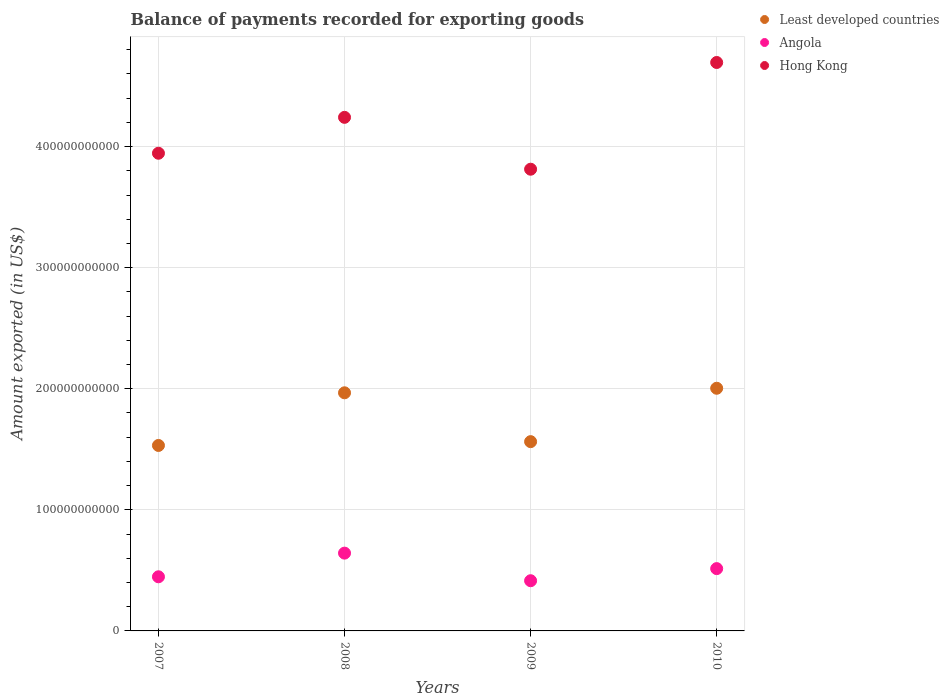How many different coloured dotlines are there?
Your response must be concise. 3. What is the amount exported in Least developed countries in 2009?
Offer a terse response. 1.56e+11. Across all years, what is the maximum amount exported in Angola?
Offer a terse response. 6.42e+1. Across all years, what is the minimum amount exported in Hong Kong?
Give a very brief answer. 3.81e+11. What is the total amount exported in Hong Kong in the graph?
Provide a short and direct response. 1.67e+12. What is the difference between the amount exported in Hong Kong in 2007 and that in 2010?
Your response must be concise. -7.50e+1. What is the difference between the amount exported in Least developed countries in 2009 and the amount exported in Hong Kong in 2007?
Your response must be concise. -2.38e+11. What is the average amount exported in Hong Kong per year?
Provide a succinct answer. 4.17e+11. In the year 2007, what is the difference between the amount exported in Angola and amount exported in Least developed countries?
Ensure brevity in your answer.  -1.08e+11. What is the ratio of the amount exported in Angola in 2007 to that in 2009?
Provide a succinct answer. 1.08. Is the amount exported in Least developed countries in 2008 less than that in 2009?
Provide a succinct answer. No. Is the difference between the amount exported in Angola in 2008 and 2010 greater than the difference between the amount exported in Least developed countries in 2008 and 2010?
Ensure brevity in your answer.  Yes. What is the difference between the highest and the second highest amount exported in Hong Kong?
Your response must be concise. 4.53e+1. What is the difference between the highest and the lowest amount exported in Angola?
Your answer should be very brief. 2.28e+1. In how many years, is the amount exported in Angola greater than the average amount exported in Angola taken over all years?
Provide a succinct answer. 2. Is the sum of the amount exported in Least developed countries in 2009 and 2010 greater than the maximum amount exported in Hong Kong across all years?
Keep it short and to the point. No. Does the amount exported in Angola monotonically increase over the years?
Your answer should be very brief. No. How many dotlines are there?
Provide a succinct answer. 3. What is the difference between two consecutive major ticks on the Y-axis?
Provide a succinct answer. 1.00e+11. Does the graph contain any zero values?
Keep it short and to the point. No. What is the title of the graph?
Your answer should be compact. Balance of payments recorded for exporting goods. What is the label or title of the Y-axis?
Your response must be concise. Amount exported (in US$). What is the Amount exported (in US$) of Least developed countries in 2007?
Offer a very short reply. 1.53e+11. What is the Amount exported (in US$) of Angola in 2007?
Ensure brevity in your answer.  4.47e+1. What is the Amount exported (in US$) of Hong Kong in 2007?
Offer a very short reply. 3.94e+11. What is the Amount exported (in US$) of Least developed countries in 2008?
Keep it short and to the point. 1.97e+11. What is the Amount exported (in US$) of Angola in 2008?
Keep it short and to the point. 6.42e+1. What is the Amount exported (in US$) in Hong Kong in 2008?
Make the answer very short. 4.24e+11. What is the Amount exported (in US$) in Least developed countries in 2009?
Make the answer very short. 1.56e+11. What is the Amount exported (in US$) in Angola in 2009?
Provide a short and direct response. 4.15e+1. What is the Amount exported (in US$) in Hong Kong in 2009?
Provide a short and direct response. 3.81e+11. What is the Amount exported (in US$) of Least developed countries in 2010?
Make the answer very short. 2.00e+11. What is the Amount exported (in US$) in Angola in 2010?
Ensure brevity in your answer.  5.15e+1. What is the Amount exported (in US$) in Hong Kong in 2010?
Your response must be concise. 4.69e+11. Across all years, what is the maximum Amount exported (in US$) of Least developed countries?
Keep it short and to the point. 2.00e+11. Across all years, what is the maximum Amount exported (in US$) of Angola?
Make the answer very short. 6.42e+1. Across all years, what is the maximum Amount exported (in US$) of Hong Kong?
Provide a short and direct response. 4.69e+11. Across all years, what is the minimum Amount exported (in US$) of Least developed countries?
Ensure brevity in your answer.  1.53e+11. Across all years, what is the minimum Amount exported (in US$) of Angola?
Ensure brevity in your answer.  4.15e+1. Across all years, what is the minimum Amount exported (in US$) of Hong Kong?
Provide a succinct answer. 3.81e+11. What is the total Amount exported (in US$) of Least developed countries in the graph?
Your response must be concise. 7.07e+11. What is the total Amount exported (in US$) of Angola in the graph?
Give a very brief answer. 2.02e+11. What is the total Amount exported (in US$) in Hong Kong in the graph?
Make the answer very short. 1.67e+12. What is the difference between the Amount exported (in US$) in Least developed countries in 2007 and that in 2008?
Provide a succinct answer. -4.35e+1. What is the difference between the Amount exported (in US$) in Angola in 2007 and that in 2008?
Make the answer very short. -1.95e+1. What is the difference between the Amount exported (in US$) in Hong Kong in 2007 and that in 2008?
Your response must be concise. -2.96e+1. What is the difference between the Amount exported (in US$) of Least developed countries in 2007 and that in 2009?
Keep it short and to the point. -3.15e+09. What is the difference between the Amount exported (in US$) in Angola in 2007 and that in 2009?
Provide a succinct answer. 3.26e+09. What is the difference between the Amount exported (in US$) of Hong Kong in 2007 and that in 2009?
Give a very brief answer. 1.32e+1. What is the difference between the Amount exported (in US$) of Least developed countries in 2007 and that in 2010?
Your answer should be compact. -4.72e+1. What is the difference between the Amount exported (in US$) of Angola in 2007 and that in 2010?
Offer a terse response. -6.74e+09. What is the difference between the Amount exported (in US$) of Hong Kong in 2007 and that in 2010?
Your answer should be compact. -7.50e+1. What is the difference between the Amount exported (in US$) of Least developed countries in 2008 and that in 2009?
Your response must be concise. 4.03e+1. What is the difference between the Amount exported (in US$) of Angola in 2008 and that in 2009?
Your answer should be very brief. 2.28e+1. What is the difference between the Amount exported (in US$) in Hong Kong in 2008 and that in 2009?
Ensure brevity in your answer.  4.28e+1. What is the difference between the Amount exported (in US$) in Least developed countries in 2008 and that in 2010?
Offer a very short reply. -3.75e+09. What is the difference between the Amount exported (in US$) in Angola in 2008 and that in 2010?
Your answer should be very brief. 1.28e+1. What is the difference between the Amount exported (in US$) of Hong Kong in 2008 and that in 2010?
Offer a terse response. -4.53e+1. What is the difference between the Amount exported (in US$) in Least developed countries in 2009 and that in 2010?
Offer a terse response. -4.41e+1. What is the difference between the Amount exported (in US$) of Angola in 2009 and that in 2010?
Keep it short and to the point. -1.00e+1. What is the difference between the Amount exported (in US$) of Hong Kong in 2009 and that in 2010?
Your response must be concise. -8.81e+1. What is the difference between the Amount exported (in US$) of Least developed countries in 2007 and the Amount exported (in US$) of Angola in 2008?
Make the answer very short. 8.89e+1. What is the difference between the Amount exported (in US$) of Least developed countries in 2007 and the Amount exported (in US$) of Hong Kong in 2008?
Your response must be concise. -2.71e+11. What is the difference between the Amount exported (in US$) in Angola in 2007 and the Amount exported (in US$) in Hong Kong in 2008?
Make the answer very short. -3.79e+11. What is the difference between the Amount exported (in US$) of Least developed countries in 2007 and the Amount exported (in US$) of Angola in 2009?
Provide a short and direct response. 1.12e+11. What is the difference between the Amount exported (in US$) in Least developed countries in 2007 and the Amount exported (in US$) in Hong Kong in 2009?
Keep it short and to the point. -2.28e+11. What is the difference between the Amount exported (in US$) of Angola in 2007 and the Amount exported (in US$) of Hong Kong in 2009?
Keep it short and to the point. -3.37e+11. What is the difference between the Amount exported (in US$) in Least developed countries in 2007 and the Amount exported (in US$) in Angola in 2010?
Offer a very short reply. 1.02e+11. What is the difference between the Amount exported (in US$) in Least developed countries in 2007 and the Amount exported (in US$) in Hong Kong in 2010?
Offer a very short reply. -3.16e+11. What is the difference between the Amount exported (in US$) of Angola in 2007 and the Amount exported (in US$) of Hong Kong in 2010?
Keep it short and to the point. -4.25e+11. What is the difference between the Amount exported (in US$) of Least developed countries in 2008 and the Amount exported (in US$) of Angola in 2009?
Offer a very short reply. 1.55e+11. What is the difference between the Amount exported (in US$) of Least developed countries in 2008 and the Amount exported (in US$) of Hong Kong in 2009?
Give a very brief answer. -1.85e+11. What is the difference between the Amount exported (in US$) of Angola in 2008 and the Amount exported (in US$) of Hong Kong in 2009?
Ensure brevity in your answer.  -3.17e+11. What is the difference between the Amount exported (in US$) of Least developed countries in 2008 and the Amount exported (in US$) of Angola in 2010?
Your response must be concise. 1.45e+11. What is the difference between the Amount exported (in US$) in Least developed countries in 2008 and the Amount exported (in US$) in Hong Kong in 2010?
Your answer should be compact. -2.73e+11. What is the difference between the Amount exported (in US$) of Angola in 2008 and the Amount exported (in US$) of Hong Kong in 2010?
Provide a short and direct response. -4.05e+11. What is the difference between the Amount exported (in US$) of Least developed countries in 2009 and the Amount exported (in US$) of Angola in 2010?
Provide a succinct answer. 1.05e+11. What is the difference between the Amount exported (in US$) in Least developed countries in 2009 and the Amount exported (in US$) in Hong Kong in 2010?
Provide a short and direct response. -3.13e+11. What is the difference between the Amount exported (in US$) of Angola in 2009 and the Amount exported (in US$) of Hong Kong in 2010?
Your answer should be compact. -4.28e+11. What is the average Amount exported (in US$) in Least developed countries per year?
Your answer should be compact. 1.77e+11. What is the average Amount exported (in US$) of Angola per year?
Provide a short and direct response. 5.05e+1. What is the average Amount exported (in US$) of Hong Kong per year?
Offer a very short reply. 4.17e+11. In the year 2007, what is the difference between the Amount exported (in US$) of Least developed countries and Amount exported (in US$) of Angola?
Your answer should be compact. 1.08e+11. In the year 2007, what is the difference between the Amount exported (in US$) in Least developed countries and Amount exported (in US$) in Hong Kong?
Your answer should be very brief. -2.41e+11. In the year 2007, what is the difference between the Amount exported (in US$) in Angola and Amount exported (in US$) in Hong Kong?
Your answer should be compact. -3.50e+11. In the year 2008, what is the difference between the Amount exported (in US$) of Least developed countries and Amount exported (in US$) of Angola?
Your answer should be compact. 1.32e+11. In the year 2008, what is the difference between the Amount exported (in US$) in Least developed countries and Amount exported (in US$) in Hong Kong?
Your answer should be very brief. -2.27e+11. In the year 2008, what is the difference between the Amount exported (in US$) of Angola and Amount exported (in US$) of Hong Kong?
Offer a terse response. -3.60e+11. In the year 2009, what is the difference between the Amount exported (in US$) of Least developed countries and Amount exported (in US$) of Angola?
Keep it short and to the point. 1.15e+11. In the year 2009, what is the difference between the Amount exported (in US$) in Least developed countries and Amount exported (in US$) in Hong Kong?
Provide a short and direct response. -2.25e+11. In the year 2009, what is the difference between the Amount exported (in US$) of Angola and Amount exported (in US$) of Hong Kong?
Your answer should be compact. -3.40e+11. In the year 2010, what is the difference between the Amount exported (in US$) in Least developed countries and Amount exported (in US$) in Angola?
Ensure brevity in your answer.  1.49e+11. In the year 2010, what is the difference between the Amount exported (in US$) of Least developed countries and Amount exported (in US$) of Hong Kong?
Give a very brief answer. -2.69e+11. In the year 2010, what is the difference between the Amount exported (in US$) of Angola and Amount exported (in US$) of Hong Kong?
Give a very brief answer. -4.18e+11. What is the ratio of the Amount exported (in US$) in Least developed countries in 2007 to that in 2008?
Keep it short and to the point. 0.78. What is the ratio of the Amount exported (in US$) of Angola in 2007 to that in 2008?
Your answer should be very brief. 0.7. What is the ratio of the Amount exported (in US$) in Hong Kong in 2007 to that in 2008?
Give a very brief answer. 0.93. What is the ratio of the Amount exported (in US$) of Least developed countries in 2007 to that in 2009?
Your response must be concise. 0.98. What is the ratio of the Amount exported (in US$) of Angola in 2007 to that in 2009?
Ensure brevity in your answer.  1.08. What is the ratio of the Amount exported (in US$) in Hong Kong in 2007 to that in 2009?
Make the answer very short. 1.03. What is the ratio of the Amount exported (in US$) of Least developed countries in 2007 to that in 2010?
Your response must be concise. 0.76. What is the ratio of the Amount exported (in US$) in Angola in 2007 to that in 2010?
Your answer should be compact. 0.87. What is the ratio of the Amount exported (in US$) of Hong Kong in 2007 to that in 2010?
Your answer should be compact. 0.84. What is the ratio of the Amount exported (in US$) of Least developed countries in 2008 to that in 2009?
Offer a very short reply. 1.26. What is the ratio of the Amount exported (in US$) in Angola in 2008 to that in 2009?
Your response must be concise. 1.55. What is the ratio of the Amount exported (in US$) of Hong Kong in 2008 to that in 2009?
Keep it short and to the point. 1.11. What is the ratio of the Amount exported (in US$) of Least developed countries in 2008 to that in 2010?
Ensure brevity in your answer.  0.98. What is the ratio of the Amount exported (in US$) in Angola in 2008 to that in 2010?
Give a very brief answer. 1.25. What is the ratio of the Amount exported (in US$) of Hong Kong in 2008 to that in 2010?
Your answer should be compact. 0.9. What is the ratio of the Amount exported (in US$) of Least developed countries in 2009 to that in 2010?
Give a very brief answer. 0.78. What is the ratio of the Amount exported (in US$) of Angola in 2009 to that in 2010?
Provide a succinct answer. 0.81. What is the ratio of the Amount exported (in US$) of Hong Kong in 2009 to that in 2010?
Ensure brevity in your answer.  0.81. What is the difference between the highest and the second highest Amount exported (in US$) in Least developed countries?
Make the answer very short. 3.75e+09. What is the difference between the highest and the second highest Amount exported (in US$) of Angola?
Your answer should be very brief. 1.28e+1. What is the difference between the highest and the second highest Amount exported (in US$) of Hong Kong?
Offer a very short reply. 4.53e+1. What is the difference between the highest and the lowest Amount exported (in US$) of Least developed countries?
Keep it short and to the point. 4.72e+1. What is the difference between the highest and the lowest Amount exported (in US$) of Angola?
Give a very brief answer. 2.28e+1. What is the difference between the highest and the lowest Amount exported (in US$) in Hong Kong?
Your answer should be very brief. 8.81e+1. 